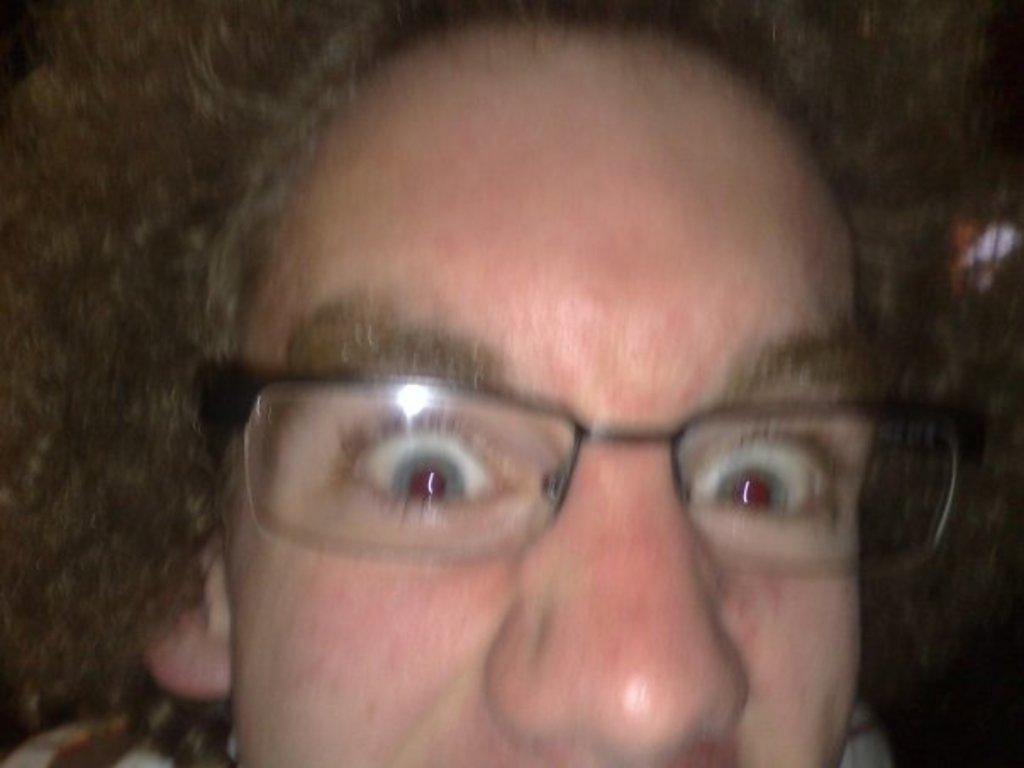What is present in the image? There is a person in the image. Can you describe the person's appearance? The person's face is visible in the image. What accessory is the person wearing? The person is wearing spectacles. What type of receipt is the person holding in the image? There is no receipt present in the image. How many quarters can be seen in the person's hand in the image? There are no quarters visible in the image. 